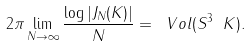Convert formula to latex. <formula><loc_0><loc_0><loc_500><loc_500>2 \pi \lim _ { N \to \infty } \frac { \log | J _ { N } ( K ) | } { N } = \ V o l ( S ^ { 3 } \ K ) .</formula> 